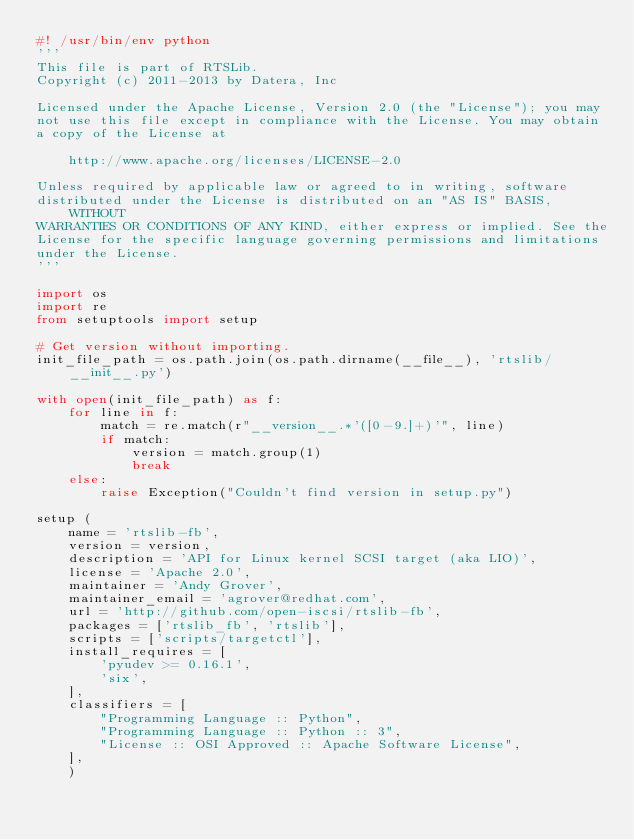<code> <loc_0><loc_0><loc_500><loc_500><_Python_>#! /usr/bin/env python
'''
This file is part of RTSLib.
Copyright (c) 2011-2013 by Datera, Inc

Licensed under the Apache License, Version 2.0 (the "License"); you may
not use this file except in compliance with the License. You may obtain
a copy of the License at

    http://www.apache.org/licenses/LICENSE-2.0

Unless required by applicable law or agreed to in writing, software
distributed under the License is distributed on an "AS IS" BASIS, WITHOUT
WARRANTIES OR CONDITIONS OF ANY KIND, either express or implied. See the
License for the specific language governing permissions and limitations
under the License.
'''

import os
import re
from setuptools import setup

# Get version without importing.
init_file_path = os.path.join(os.path.dirname(__file__), 'rtslib/__init__.py')

with open(init_file_path) as f:
    for line in f:
        match = re.match(r"__version__.*'([0-9.]+)'", line)
        if match:
            version = match.group(1)
            break
    else:
        raise Exception("Couldn't find version in setup.py")

setup (
    name = 'rtslib-fb',
    version = version,
    description = 'API for Linux kernel SCSI target (aka LIO)',
    license = 'Apache 2.0',
    maintainer = 'Andy Grover',
    maintainer_email = 'agrover@redhat.com',
    url = 'http://github.com/open-iscsi/rtslib-fb',
    packages = ['rtslib_fb', 'rtslib'],
    scripts = ['scripts/targetctl'],
    install_requires = [
        'pyudev >= 0.16.1',
        'six',
    ],
    classifiers = [
        "Programming Language :: Python",
        "Programming Language :: Python :: 3",
        "License :: OSI Approved :: Apache Software License",
    ],
    )
</code> 